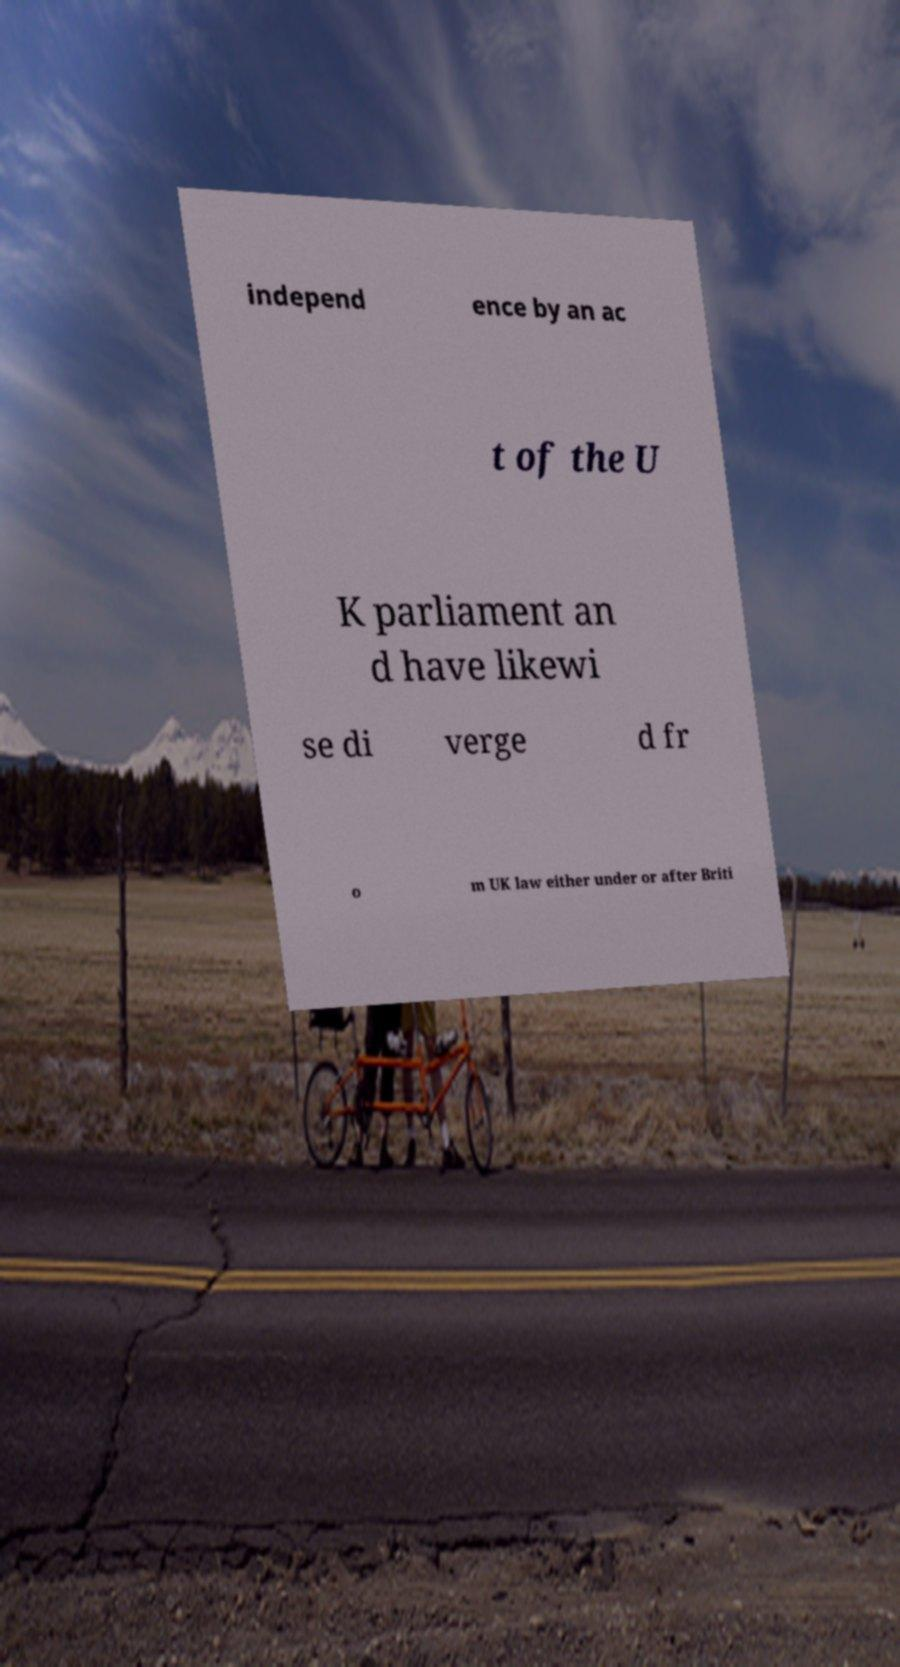I need the written content from this picture converted into text. Can you do that? independ ence by an ac t of the U K parliament an d have likewi se di verge d fr o m UK law either under or after Briti 